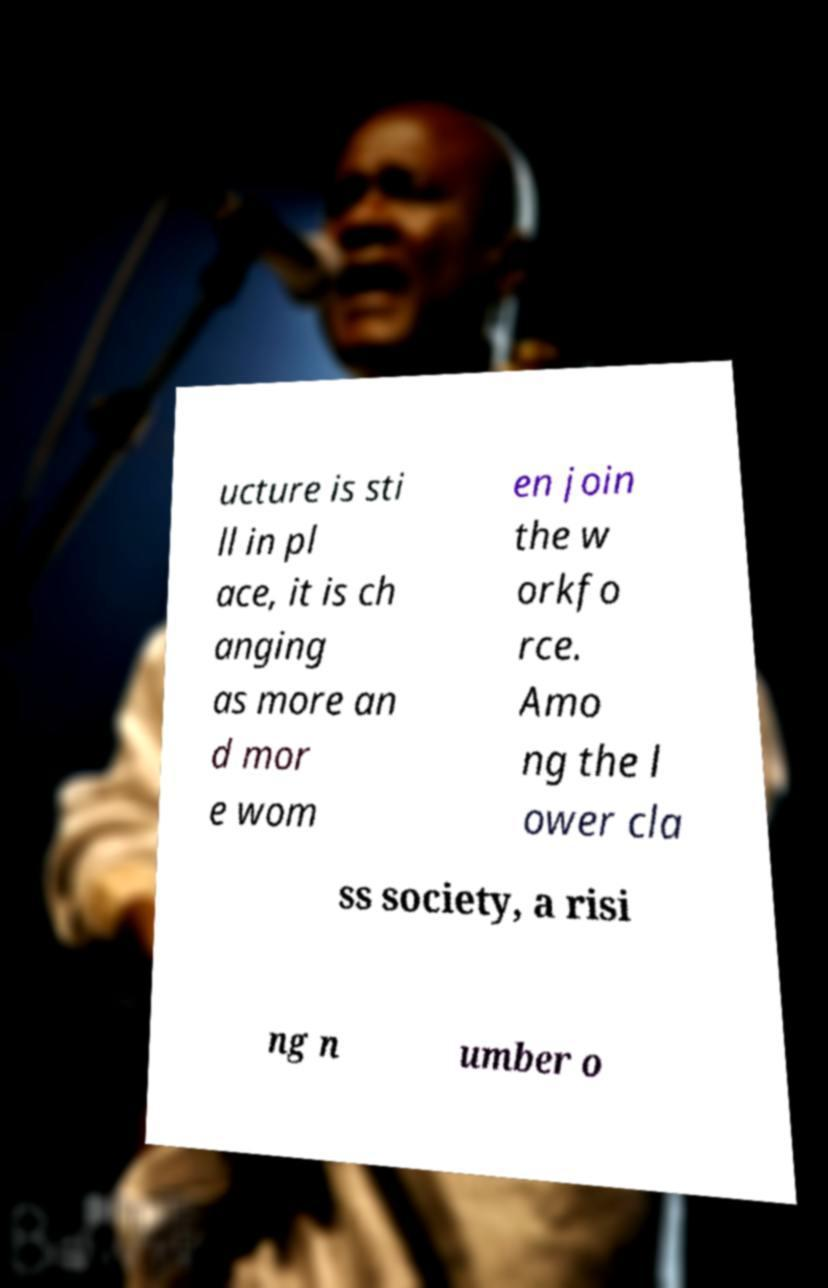What messages or text are displayed in this image? I need them in a readable, typed format. ucture is sti ll in pl ace, it is ch anging as more an d mor e wom en join the w orkfo rce. Amo ng the l ower cla ss society, a risi ng n umber o 